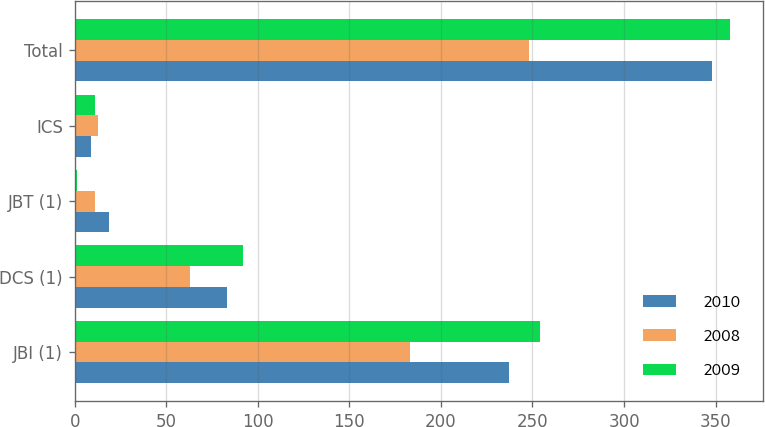Convert chart to OTSL. <chart><loc_0><loc_0><loc_500><loc_500><stacked_bar_chart><ecel><fcel>JBI (1)<fcel>DCS (1)<fcel>JBT (1)<fcel>ICS<fcel>Total<nl><fcel>2010<fcel>237<fcel>83<fcel>19<fcel>9<fcel>348<nl><fcel>2008<fcel>183<fcel>63<fcel>11<fcel>13<fcel>248<nl><fcel>2009<fcel>254<fcel>92<fcel>1<fcel>11<fcel>358<nl></chart> 